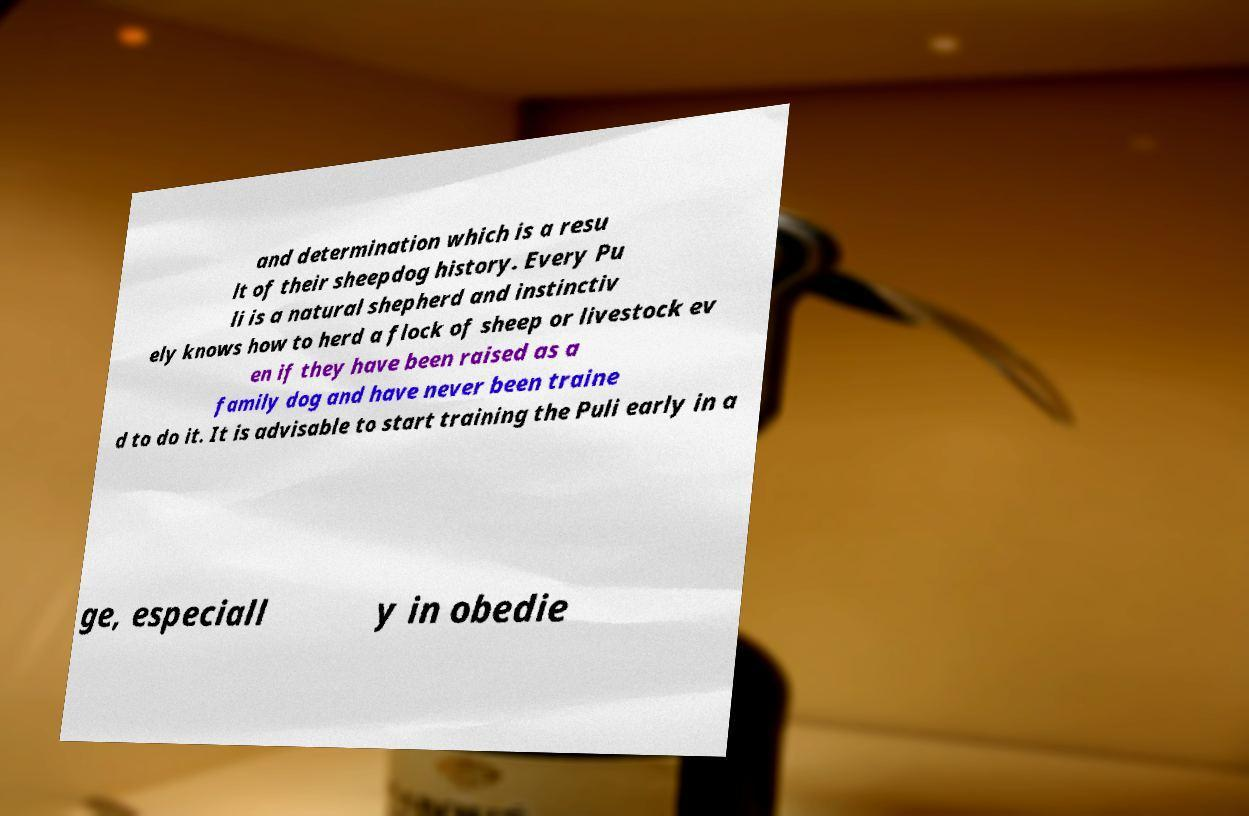Please read and relay the text visible in this image. What does it say? and determination which is a resu lt of their sheepdog history. Every Pu li is a natural shepherd and instinctiv ely knows how to herd a flock of sheep or livestock ev en if they have been raised as a family dog and have never been traine d to do it. It is advisable to start training the Puli early in a ge, especiall y in obedie 